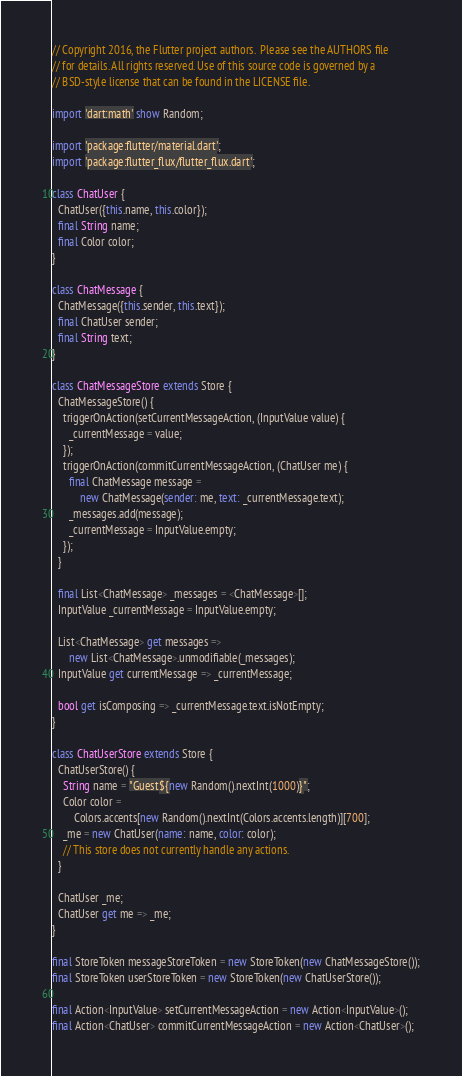<code> <loc_0><loc_0><loc_500><loc_500><_Dart_>// Copyright 2016, the Flutter project authors.  Please see the AUTHORS file
// for details. All rights reserved. Use of this source code is governed by a
// BSD-style license that can be found in the LICENSE file.

import 'dart:math' show Random;

import 'package:flutter/material.dart';
import 'package:flutter_flux/flutter_flux.dart';

class ChatUser {
  ChatUser({this.name, this.color});
  final String name;
  final Color color;
}

class ChatMessage {
  ChatMessage({this.sender, this.text});
  final ChatUser sender;
  final String text;
}

class ChatMessageStore extends Store {
  ChatMessageStore() {
    triggerOnAction(setCurrentMessageAction, (InputValue value) {
      _currentMessage = value;
    });
    triggerOnAction(commitCurrentMessageAction, (ChatUser me) {
      final ChatMessage message =
          new ChatMessage(sender: me, text: _currentMessage.text);
      _messages.add(message);
      _currentMessage = InputValue.empty;
    });
  }

  final List<ChatMessage> _messages = <ChatMessage>[];
  InputValue _currentMessage = InputValue.empty;

  List<ChatMessage> get messages =>
      new List<ChatMessage>.unmodifiable(_messages);
  InputValue get currentMessage => _currentMessage;

  bool get isComposing => _currentMessage.text.isNotEmpty;
}

class ChatUserStore extends Store {
  ChatUserStore() {
    String name = "Guest${new Random().nextInt(1000)}";
    Color color =
        Colors.accents[new Random().nextInt(Colors.accents.length)][700];
    _me = new ChatUser(name: name, color: color);
    // This store does not currently handle any actions.
  }

  ChatUser _me;
  ChatUser get me => _me;
}

final StoreToken messageStoreToken = new StoreToken(new ChatMessageStore());
final StoreToken userStoreToken = new StoreToken(new ChatUserStore());

final Action<InputValue> setCurrentMessageAction = new Action<InputValue>();
final Action<ChatUser> commitCurrentMessageAction = new Action<ChatUser>();
</code> 